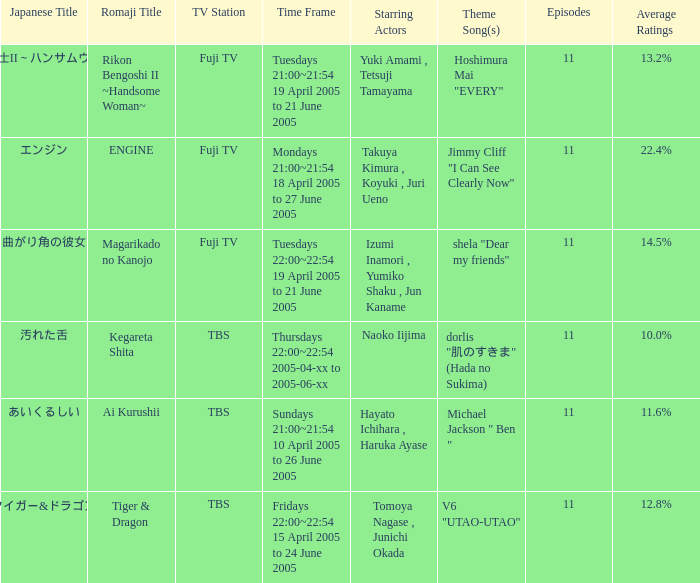Who is the star of the program on Thursdays 22:00~22:54 2005-04-xx to 2005-06-xx? Naoko Iijima. 